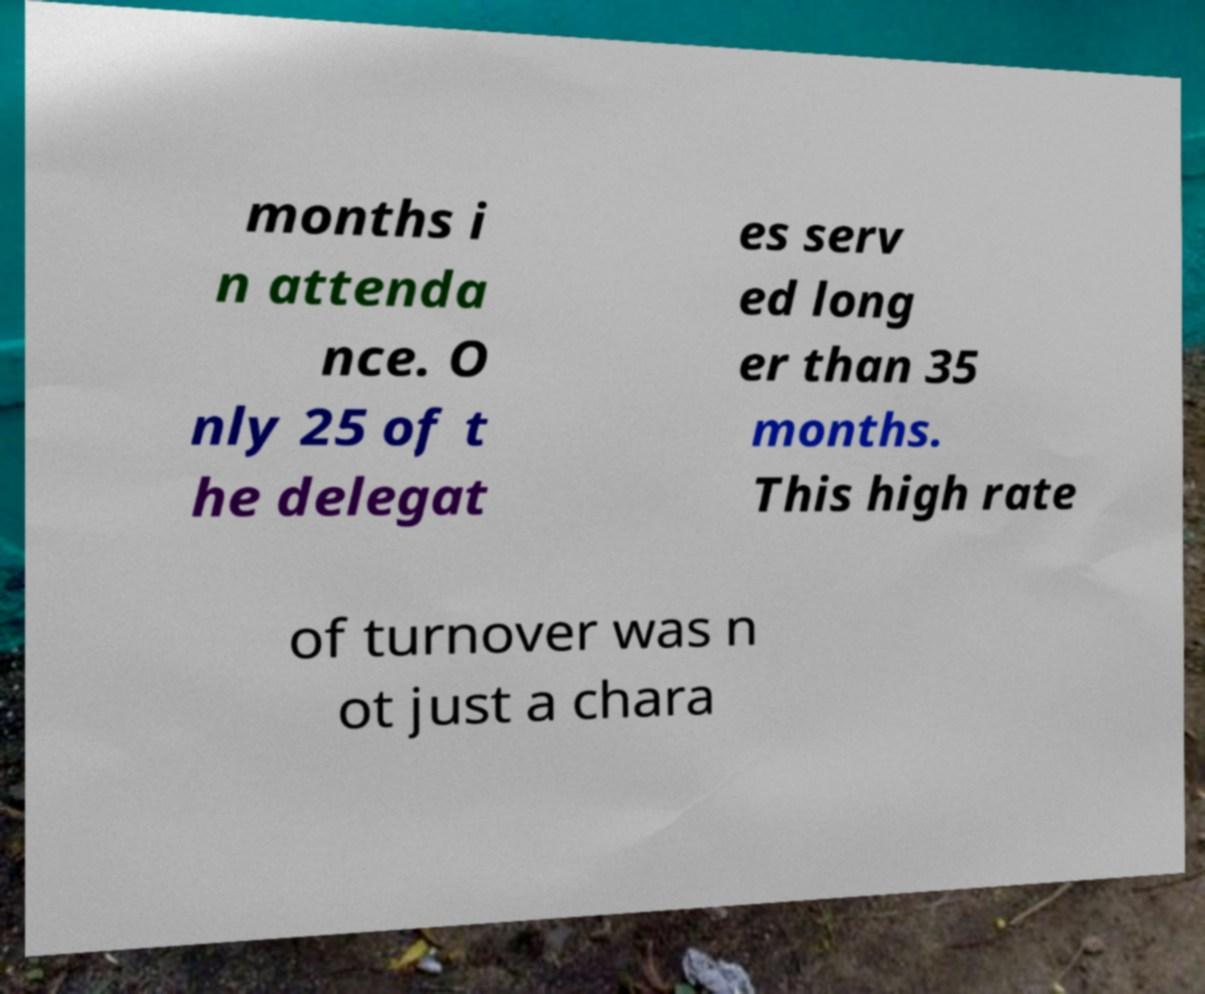Could you extract and type out the text from this image? months i n attenda nce. O nly 25 of t he delegat es serv ed long er than 35 months. This high rate of turnover was n ot just a chara 